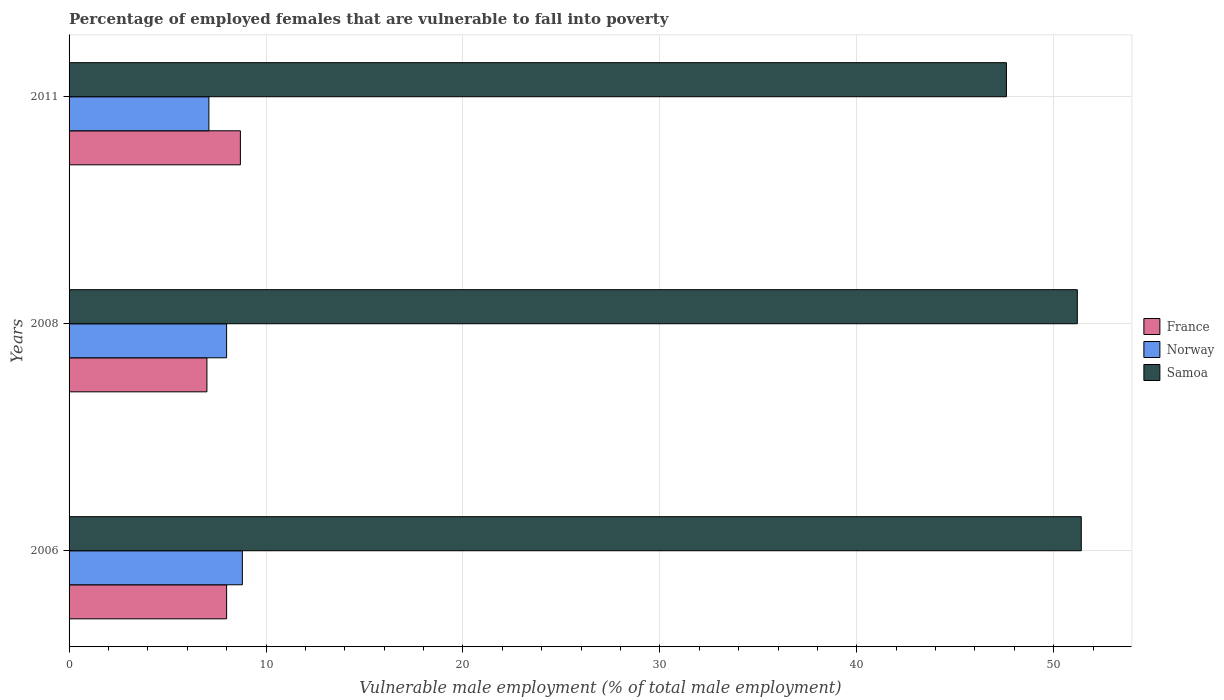How many different coloured bars are there?
Keep it short and to the point. 3. How many groups of bars are there?
Offer a terse response. 3. Are the number of bars per tick equal to the number of legend labels?
Your response must be concise. Yes. Are the number of bars on each tick of the Y-axis equal?
Make the answer very short. Yes. How many bars are there on the 3rd tick from the top?
Keep it short and to the point. 3. How many bars are there on the 3rd tick from the bottom?
Make the answer very short. 3. What is the label of the 3rd group of bars from the top?
Offer a very short reply. 2006. What is the percentage of employed females who are vulnerable to fall into poverty in Norway in 2006?
Provide a short and direct response. 8.8. Across all years, what is the maximum percentage of employed females who are vulnerable to fall into poverty in Norway?
Your answer should be very brief. 8.8. Across all years, what is the minimum percentage of employed females who are vulnerable to fall into poverty in Norway?
Keep it short and to the point. 7.1. What is the total percentage of employed females who are vulnerable to fall into poverty in Samoa in the graph?
Your response must be concise. 150.2. What is the difference between the percentage of employed females who are vulnerable to fall into poverty in Norway in 2006 and that in 2011?
Ensure brevity in your answer.  1.7. What is the difference between the percentage of employed females who are vulnerable to fall into poverty in France in 2011 and the percentage of employed females who are vulnerable to fall into poverty in Samoa in 2008?
Offer a terse response. -42.5. What is the average percentage of employed females who are vulnerable to fall into poverty in Samoa per year?
Your answer should be very brief. 50.07. In the year 2011, what is the difference between the percentage of employed females who are vulnerable to fall into poverty in Norway and percentage of employed females who are vulnerable to fall into poverty in Samoa?
Keep it short and to the point. -40.5. What is the ratio of the percentage of employed females who are vulnerable to fall into poverty in France in 2008 to that in 2011?
Provide a short and direct response. 0.8. Is the percentage of employed females who are vulnerable to fall into poverty in France in 2006 less than that in 2011?
Ensure brevity in your answer.  Yes. What is the difference between the highest and the second highest percentage of employed females who are vulnerable to fall into poverty in Samoa?
Offer a very short reply. 0.2. What is the difference between the highest and the lowest percentage of employed females who are vulnerable to fall into poverty in Samoa?
Make the answer very short. 3.8. What does the 3rd bar from the top in 2011 represents?
Give a very brief answer. France. What does the 1st bar from the bottom in 2008 represents?
Your answer should be very brief. France. How many bars are there?
Offer a terse response. 9. Are all the bars in the graph horizontal?
Keep it short and to the point. Yes. How many years are there in the graph?
Your answer should be very brief. 3. Does the graph contain any zero values?
Provide a succinct answer. No. Does the graph contain grids?
Make the answer very short. Yes. How are the legend labels stacked?
Your response must be concise. Vertical. What is the title of the graph?
Provide a succinct answer. Percentage of employed females that are vulnerable to fall into poverty. Does "Marshall Islands" appear as one of the legend labels in the graph?
Your response must be concise. No. What is the label or title of the X-axis?
Your answer should be compact. Vulnerable male employment (% of total male employment). What is the label or title of the Y-axis?
Your answer should be very brief. Years. What is the Vulnerable male employment (% of total male employment) of France in 2006?
Your answer should be compact. 8. What is the Vulnerable male employment (% of total male employment) of Norway in 2006?
Give a very brief answer. 8.8. What is the Vulnerable male employment (% of total male employment) of Samoa in 2006?
Ensure brevity in your answer.  51.4. What is the Vulnerable male employment (% of total male employment) in France in 2008?
Make the answer very short. 7. What is the Vulnerable male employment (% of total male employment) in Norway in 2008?
Provide a short and direct response. 8. What is the Vulnerable male employment (% of total male employment) in Samoa in 2008?
Make the answer very short. 51.2. What is the Vulnerable male employment (% of total male employment) in France in 2011?
Provide a short and direct response. 8.7. What is the Vulnerable male employment (% of total male employment) of Norway in 2011?
Ensure brevity in your answer.  7.1. What is the Vulnerable male employment (% of total male employment) in Samoa in 2011?
Provide a short and direct response. 47.6. Across all years, what is the maximum Vulnerable male employment (% of total male employment) in France?
Ensure brevity in your answer.  8.7. Across all years, what is the maximum Vulnerable male employment (% of total male employment) in Norway?
Keep it short and to the point. 8.8. Across all years, what is the maximum Vulnerable male employment (% of total male employment) of Samoa?
Keep it short and to the point. 51.4. Across all years, what is the minimum Vulnerable male employment (% of total male employment) of France?
Your answer should be compact. 7. Across all years, what is the minimum Vulnerable male employment (% of total male employment) in Norway?
Offer a terse response. 7.1. Across all years, what is the minimum Vulnerable male employment (% of total male employment) in Samoa?
Your answer should be compact. 47.6. What is the total Vulnerable male employment (% of total male employment) of France in the graph?
Ensure brevity in your answer.  23.7. What is the total Vulnerable male employment (% of total male employment) in Norway in the graph?
Your answer should be very brief. 23.9. What is the total Vulnerable male employment (% of total male employment) in Samoa in the graph?
Ensure brevity in your answer.  150.2. What is the difference between the Vulnerable male employment (% of total male employment) in France in 2006 and that in 2008?
Your answer should be compact. 1. What is the difference between the Vulnerable male employment (% of total male employment) of Norway in 2006 and that in 2008?
Keep it short and to the point. 0.8. What is the difference between the Vulnerable male employment (% of total male employment) in France in 2006 and that in 2011?
Your answer should be compact. -0.7. What is the difference between the Vulnerable male employment (% of total male employment) of Norway in 2006 and that in 2011?
Give a very brief answer. 1.7. What is the difference between the Vulnerable male employment (% of total male employment) in Samoa in 2006 and that in 2011?
Your answer should be very brief. 3.8. What is the difference between the Vulnerable male employment (% of total male employment) in France in 2008 and that in 2011?
Your answer should be compact. -1.7. What is the difference between the Vulnerable male employment (% of total male employment) in Samoa in 2008 and that in 2011?
Your answer should be compact. 3.6. What is the difference between the Vulnerable male employment (% of total male employment) in France in 2006 and the Vulnerable male employment (% of total male employment) in Norway in 2008?
Offer a terse response. 0. What is the difference between the Vulnerable male employment (% of total male employment) in France in 2006 and the Vulnerable male employment (% of total male employment) in Samoa in 2008?
Your response must be concise. -43.2. What is the difference between the Vulnerable male employment (% of total male employment) in Norway in 2006 and the Vulnerable male employment (% of total male employment) in Samoa in 2008?
Provide a succinct answer. -42.4. What is the difference between the Vulnerable male employment (% of total male employment) in France in 2006 and the Vulnerable male employment (% of total male employment) in Norway in 2011?
Give a very brief answer. 0.9. What is the difference between the Vulnerable male employment (% of total male employment) in France in 2006 and the Vulnerable male employment (% of total male employment) in Samoa in 2011?
Keep it short and to the point. -39.6. What is the difference between the Vulnerable male employment (% of total male employment) in Norway in 2006 and the Vulnerable male employment (% of total male employment) in Samoa in 2011?
Ensure brevity in your answer.  -38.8. What is the difference between the Vulnerable male employment (% of total male employment) in France in 2008 and the Vulnerable male employment (% of total male employment) in Norway in 2011?
Ensure brevity in your answer.  -0.1. What is the difference between the Vulnerable male employment (% of total male employment) in France in 2008 and the Vulnerable male employment (% of total male employment) in Samoa in 2011?
Give a very brief answer. -40.6. What is the difference between the Vulnerable male employment (% of total male employment) of Norway in 2008 and the Vulnerable male employment (% of total male employment) of Samoa in 2011?
Offer a terse response. -39.6. What is the average Vulnerable male employment (% of total male employment) in Norway per year?
Your response must be concise. 7.97. What is the average Vulnerable male employment (% of total male employment) of Samoa per year?
Keep it short and to the point. 50.07. In the year 2006, what is the difference between the Vulnerable male employment (% of total male employment) in France and Vulnerable male employment (% of total male employment) in Norway?
Provide a short and direct response. -0.8. In the year 2006, what is the difference between the Vulnerable male employment (% of total male employment) of France and Vulnerable male employment (% of total male employment) of Samoa?
Keep it short and to the point. -43.4. In the year 2006, what is the difference between the Vulnerable male employment (% of total male employment) in Norway and Vulnerable male employment (% of total male employment) in Samoa?
Offer a very short reply. -42.6. In the year 2008, what is the difference between the Vulnerable male employment (% of total male employment) of France and Vulnerable male employment (% of total male employment) of Samoa?
Offer a very short reply. -44.2. In the year 2008, what is the difference between the Vulnerable male employment (% of total male employment) in Norway and Vulnerable male employment (% of total male employment) in Samoa?
Offer a terse response. -43.2. In the year 2011, what is the difference between the Vulnerable male employment (% of total male employment) in France and Vulnerable male employment (% of total male employment) in Samoa?
Provide a short and direct response. -38.9. In the year 2011, what is the difference between the Vulnerable male employment (% of total male employment) in Norway and Vulnerable male employment (% of total male employment) in Samoa?
Your answer should be very brief. -40.5. What is the ratio of the Vulnerable male employment (% of total male employment) of France in 2006 to that in 2008?
Your answer should be compact. 1.14. What is the ratio of the Vulnerable male employment (% of total male employment) of Norway in 2006 to that in 2008?
Your answer should be very brief. 1.1. What is the ratio of the Vulnerable male employment (% of total male employment) of Samoa in 2006 to that in 2008?
Make the answer very short. 1. What is the ratio of the Vulnerable male employment (% of total male employment) of France in 2006 to that in 2011?
Provide a short and direct response. 0.92. What is the ratio of the Vulnerable male employment (% of total male employment) in Norway in 2006 to that in 2011?
Your answer should be compact. 1.24. What is the ratio of the Vulnerable male employment (% of total male employment) in Samoa in 2006 to that in 2011?
Provide a succinct answer. 1.08. What is the ratio of the Vulnerable male employment (% of total male employment) of France in 2008 to that in 2011?
Ensure brevity in your answer.  0.8. What is the ratio of the Vulnerable male employment (% of total male employment) of Norway in 2008 to that in 2011?
Give a very brief answer. 1.13. What is the ratio of the Vulnerable male employment (% of total male employment) of Samoa in 2008 to that in 2011?
Make the answer very short. 1.08. What is the difference between the highest and the second highest Vulnerable male employment (% of total male employment) in Samoa?
Make the answer very short. 0.2. What is the difference between the highest and the lowest Vulnerable male employment (% of total male employment) in Norway?
Give a very brief answer. 1.7. 